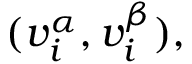Convert formula to latex. <formula><loc_0><loc_0><loc_500><loc_500>( v _ { i } ^ { \alpha } , v _ { i } ^ { \beta } ) ,</formula> 